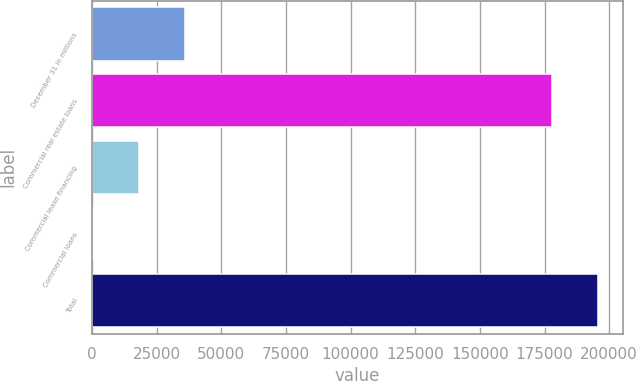Convert chart. <chart><loc_0><loc_0><loc_500><loc_500><bar_chart><fcel>December 31 in millions<fcel>Commercial real estate loans<fcel>Commercial lease financing<fcel>Commercial loans<fcel>Total<nl><fcel>36016.6<fcel>177731<fcel>18171.8<fcel>327<fcel>195576<nl></chart> 